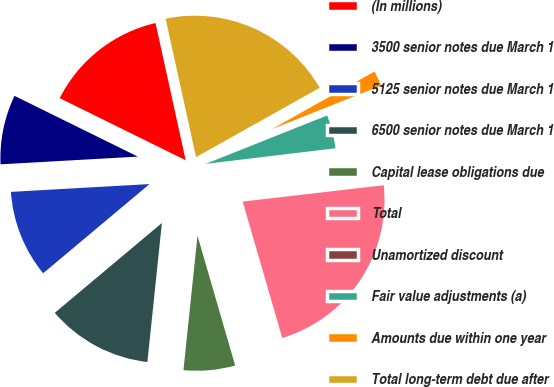Convert chart to OTSL. <chart><loc_0><loc_0><loc_500><loc_500><pie_chart><fcel>(In millions)<fcel>3500 senior notes due March 1<fcel>5125 senior notes due March 1<fcel>6500 senior notes due March 1<fcel>Capital lease obligations due<fcel>Total<fcel>Unamortized discount<fcel>Fair value adjustments (a)<fcel>Amounts due within one year<fcel>Total long-term debt due after<nl><fcel>14.27%<fcel>8.18%<fcel>10.21%<fcel>12.24%<fcel>6.15%<fcel>22.34%<fcel>0.07%<fcel>4.13%<fcel>2.1%<fcel>20.31%<nl></chart> 